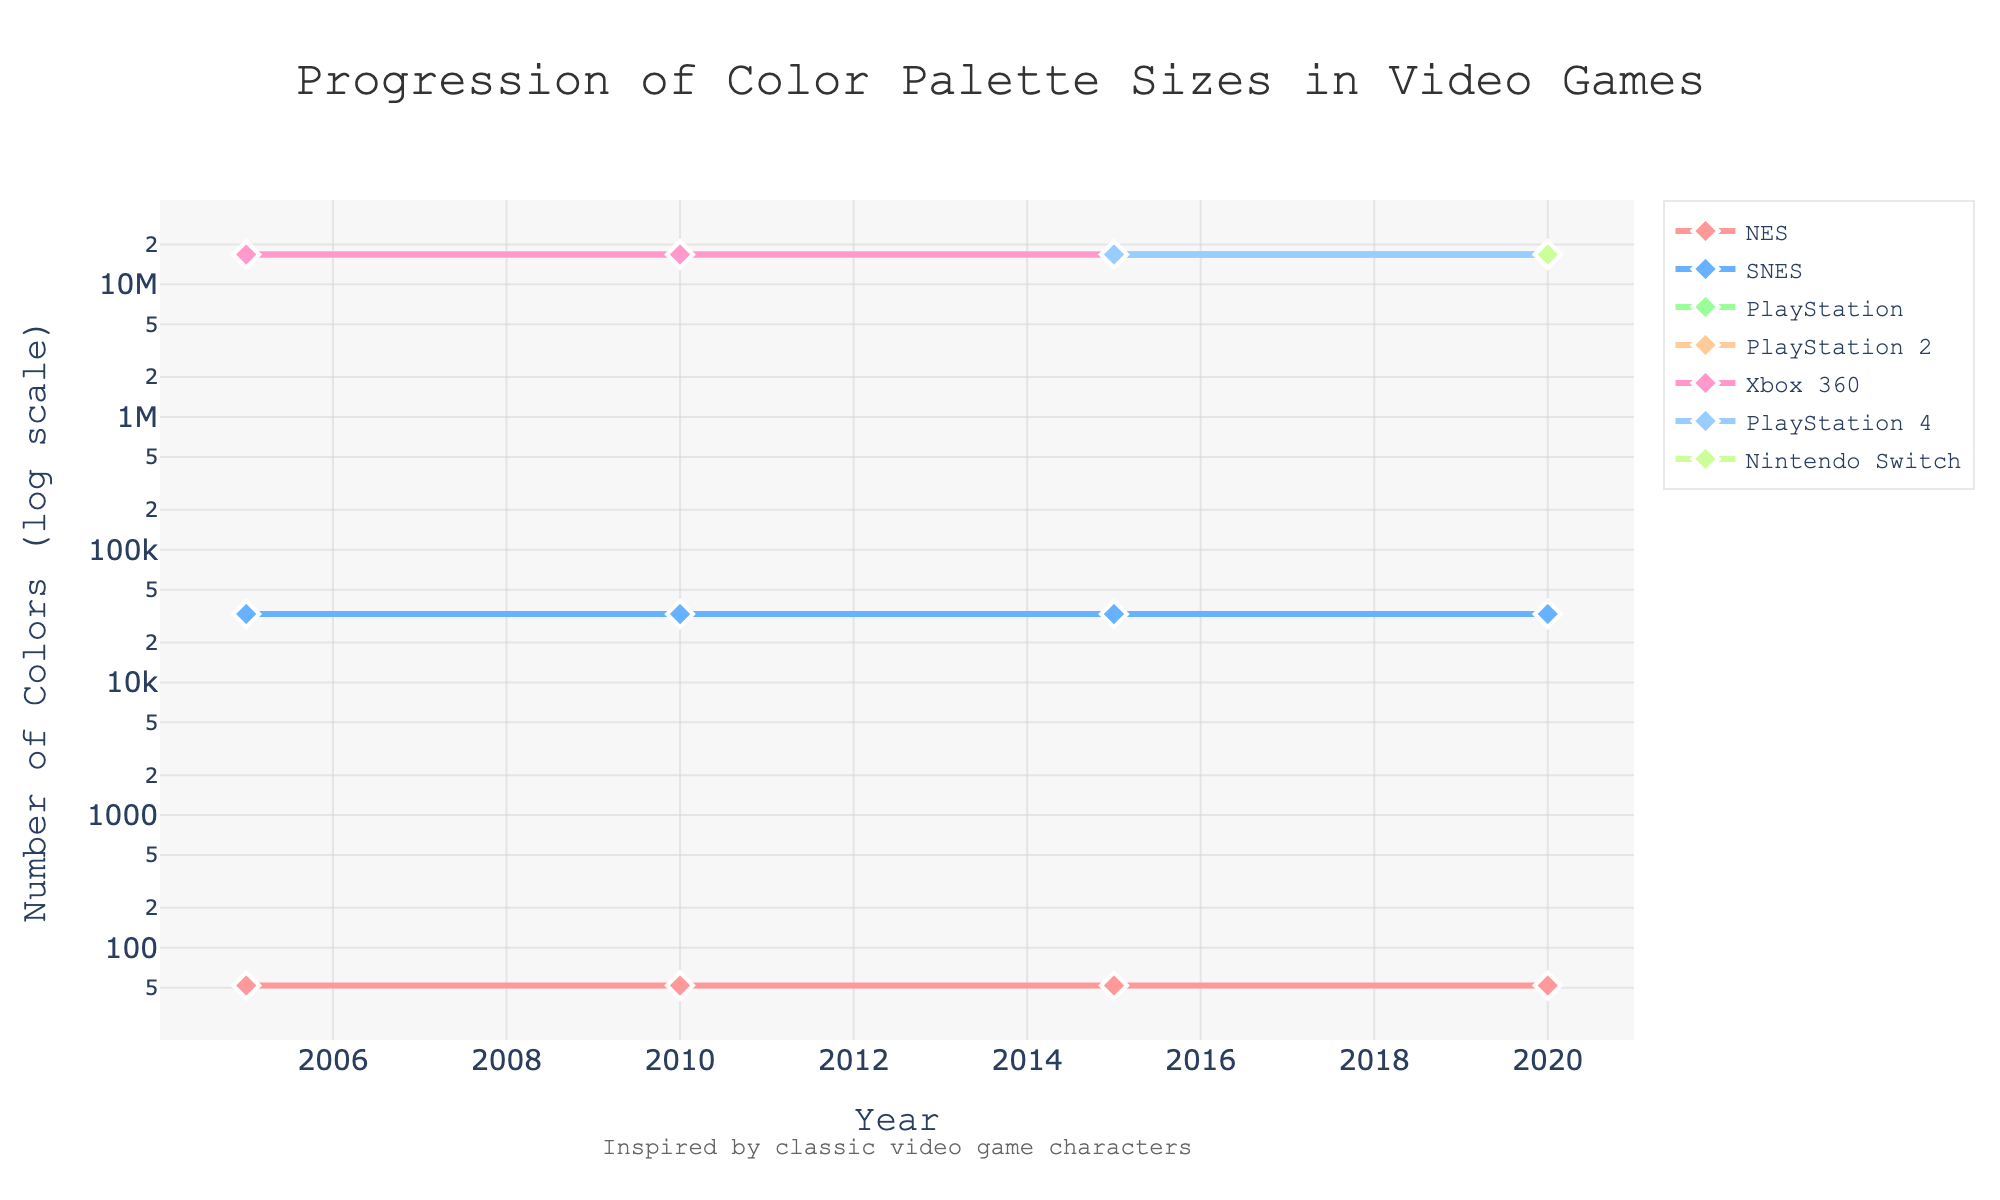Which console had the smallest color palette size in 2020? To determine which console had the smallest color palette size in 2020, find the data point for each console at the year 2020. The console data points at 2020 are: NES (52), SNES (32768), PlayStation (16777216), PlayStation 2 (16777216), Xbox 360 (16777216), PlayStation 4 (16777216), and Nintendo Switch (16777216). The smallest value is for NES, which is 52.
Answer: NES How many colors did the SNES support in 2010 and what other consoles had exactly the same number of colors in 2020? First, find the number of colors the SNES supported in 2010, which is 32768. Then, check the data points for each console at 2020 to see which consoles also supported 32768 colors. The SNES had 32768 colors in 2020, so it is the only console with exactly 32768 colors.
Answer: SNES Which consoles showed no change in their color palette sizes from 2005 to 2020? To find which consoles showed no change, compare the color palette sizes at 2005 and 2020 for each console. The consoles with the same number of colors in those years are: NES (52), SNES (32768), and PlayStation (16777216).
Answer: NES, SNES, PlayStation What is the visual difference in the line style representing PlayStation versus NES? To find the visual differences, look at the lines and markers for PlayStation and NES. PlayStation is represented with a blue line with diamond markers, while NES is represented with a red line with diamond markers.
Answer: PlayStation is blue with diamond markers; NES is red with diamond markers What number of colors marks the transition from 8-bit era (NES) to SNES and beyond? Identify the number of colors supported by NES and then compare it with SNES. NES has 52 colors, and SNES has 32768 colors, marking the transition.
Answer: 32768 How much larger is the color palette size of PlayStation compared to NES in 2015? Find the values for both consoles in 2015: PlayStation (16777216) and NES (52). Subtract the NES color count from the PlayStation color count. 16777216 - 52 = 16777164.
Answer: 16777164 Which consoles introduced significant color palette increases over their predecessors, and in which years did these increases occur? Identify the years when significant jumps occurred: from NES (52) to SNES (32768) marked a significant increase. Next significant jump is from SNES (32768) to PlayStation (16777216). These occurred from the NES to SNES era and from SNES to PlayStation era.
Answer: SNES, PlayStation; 2005 Which console shows the fastest increase in color palette size between any two consecutive data points? To find the fastest increase, examine the color palette sizes between consecutive years for each console. The jump from NES to SNES is the fastest: from 52 to 32768 colors.
Answer: SNES Which year was the biggest change in color palette size across all consoles observed, and what was the change? Review the chart for the year with the largest change across all consoles. The biggest change is seen from NES to SNES, happening from 2005 onwards, with an increase from 52 to 32768 colors.
Answer: 2005 Does the PlayStation 4's color palette size change after its initial introduction? If so, how? Identify the years PlayStation 4 data is available and compare. PlayStation 4’s color palette size in 2015 and 2020 is constantly 16777216 colors, showing no change.
Answer: No change 